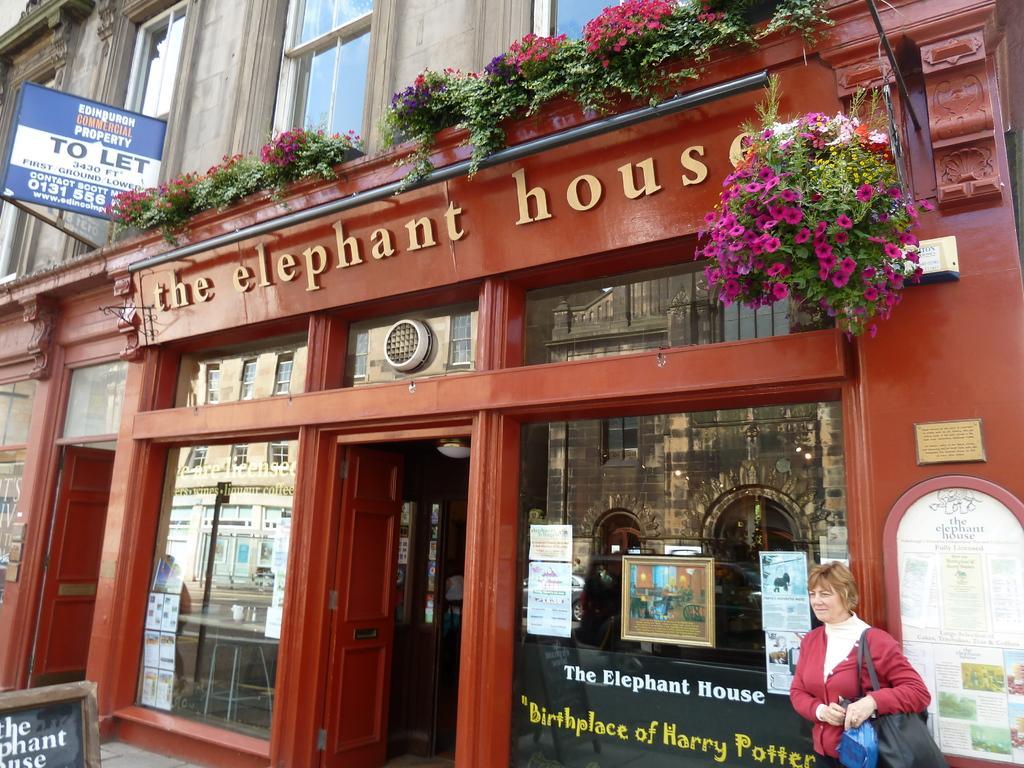In one or two sentences, can you explain what this image depicts? Here this is the outside view of a building. Here a woman is standing and holding her bag. And this building named as the elephant house. Here these are the plants having beautiful flowers. On the top there is a window, and there is also one board to the building. And this is the door. And even we can observe the reflection of building. This is the one more door which is entry to the building. 